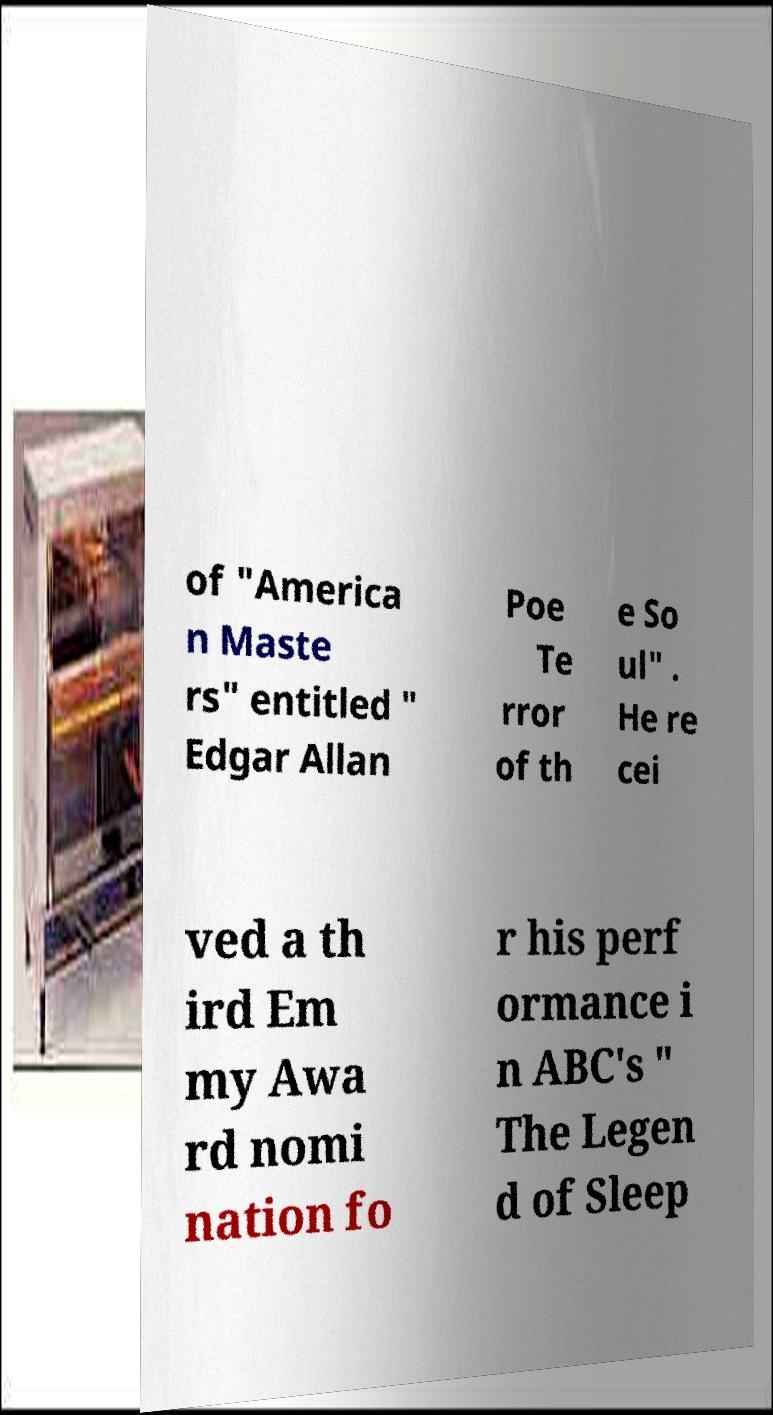I need the written content from this picture converted into text. Can you do that? of "America n Maste rs" entitled " Edgar Allan Poe Te rror of th e So ul" . He re cei ved a th ird Em my Awa rd nomi nation fo r his perf ormance i n ABC's " The Legen d of Sleep 